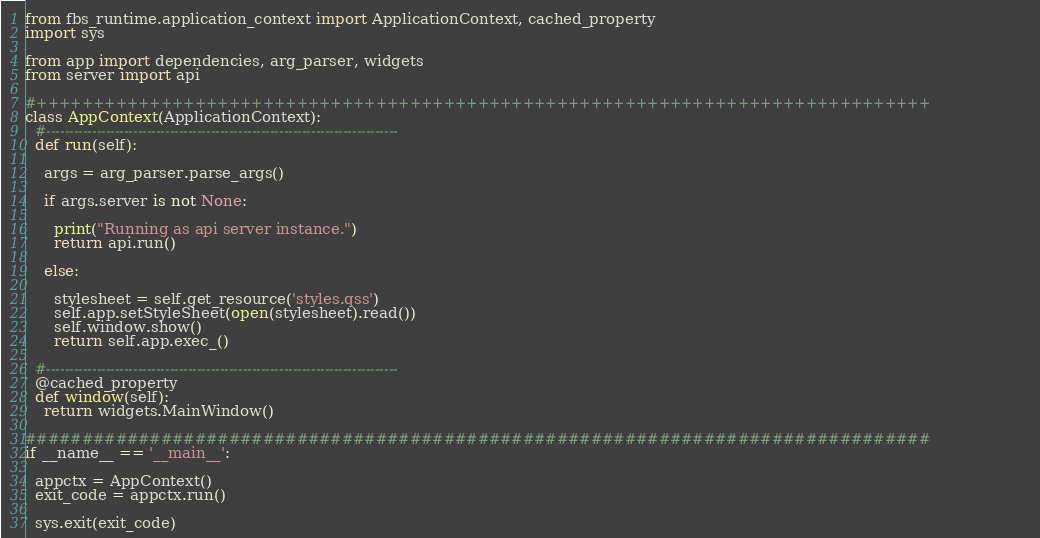Convert code to text. <code><loc_0><loc_0><loc_500><loc_500><_Python_>from fbs_runtime.application_context import ApplicationContext, cached_property
import sys

from app import dependencies, arg_parser, widgets
from server import api

#+++++++++++++++++++++++++++++++++++++++++++++++++++++++++++++++++++++++++++++++
class AppContext(ApplicationContext):
  #-----------------------------------------------------------------------------
  def run(self):

    args = arg_parser.parse_args()

    if args.server is not None:

      print("Running as api server instance.")
      return api.run()

    else:

      stylesheet = self.get_resource('styles.qss')
      self.app.setStyleSheet(open(stylesheet).read())
      self.window.show()
      return self.app.exec_()

  #-----------------------------------------------------------------------------
  @cached_property
  def window(self):
    return widgets.MainWindow()

################################################################################
if __name__ == '__main__':

  appctx = AppContext()
  exit_code = appctx.run()

  sys.exit(exit_code)
</code> 